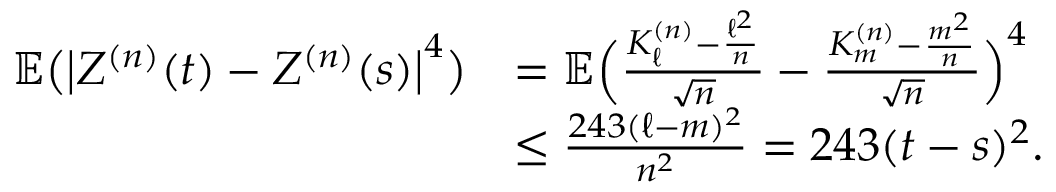Convert formula to latex. <formula><loc_0><loc_0><loc_500><loc_500>\begin{array} { r l } { \mathbb { E } \left ( \left | Z ^ { ( n ) } ( t ) - Z ^ { ( n ) } ( s ) \right | ^ { 4 } \right ) } & { = \mathbb { E } \left ( \frac { K _ { \ell } ^ { ( n ) } - \frac { \ell ^ { 2 } } { n } } { \sqrt { n } } - \frac { K _ { m } ^ { ( n ) } - \frac { m ^ { 2 } } { n } } { \sqrt { n } } \right ) ^ { 4 } } \\ & { \leq \frac { 2 4 3 ( \ell - m ) ^ { 2 } } { n ^ { 2 } } = 2 4 3 ( t - s ) ^ { 2 } . } \end{array}</formula> 